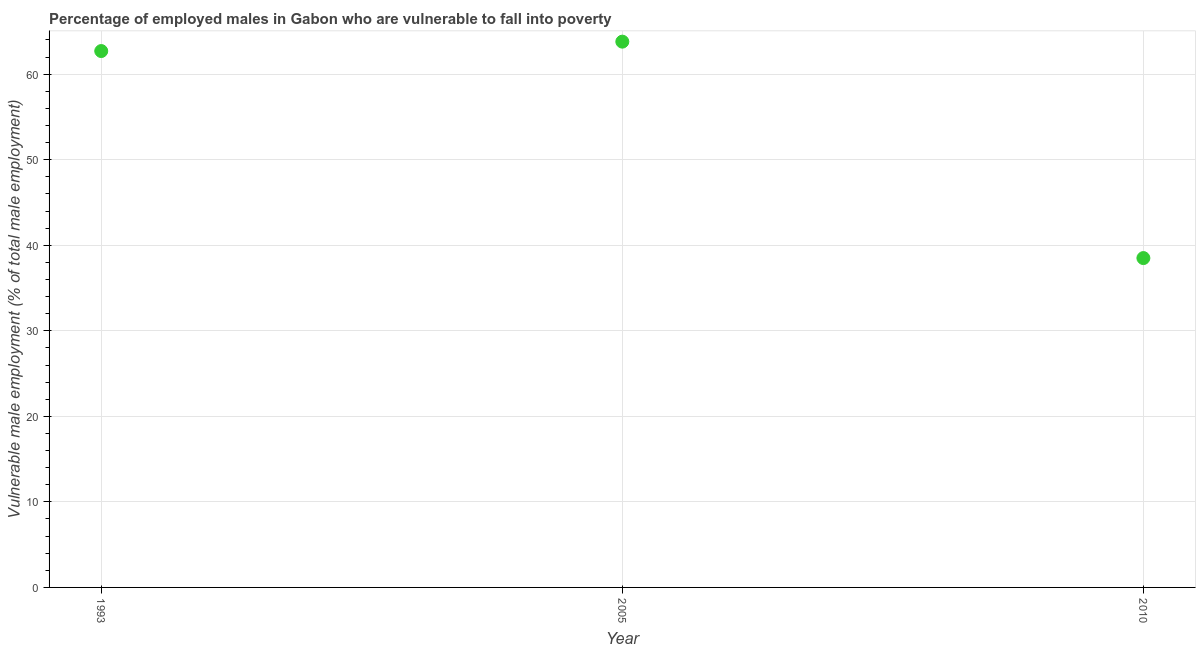What is the percentage of employed males who are vulnerable to fall into poverty in 2005?
Offer a terse response. 63.8. Across all years, what is the maximum percentage of employed males who are vulnerable to fall into poverty?
Ensure brevity in your answer.  63.8. Across all years, what is the minimum percentage of employed males who are vulnerable to fall into poverty?
Make the answer very short. 38.5. In which year was the percentage of employed males who are vulnerable to fall into poverty minimum?
Provide a short and direct response. 2010. What is the sum of the percentage of employed males who are vulnerable to fall into poverty?
Offer a terse response. 165. What is the difference between the percentage of employed males who are vulnerable to fall into poverty in 1993 and 2005?
Offer a very short reply. -1.1. What is the median percentage of employed males who are vulnerable to fall into poverty?
Your response must be concise. 62.7. What is the ratio of the percentage of employed males who are vulnerable to fall into poverty in 1993 to that in 2005?
Offer a terse response. 0.98. What is the difference between the highest and the second highest percentage of employed males who are vulnerable to fall into poverty?
Keep it short and to the point. 1.1. What is the difference between the highest and the lowest percentage of employed males who are vulnerable to fall into poverty?
Your response must be concise. 25.3. How many dotlines are there?
Give a very brief answer. 1. How many years are there in the graph?
Keep it short and to the point. 3. Are the values on the major ticks of Y-axis written in scientific E-notation?
Offer a terse response. No. What is the title of the graph?
Your answer should be compact. Percentage of employed males in Gabon who are vulnerable to fall into poverty. What is the label or title of the Y-axis?
Your answer should be compact. Vulnerable male employment (% of total male employment). What is the Vulnerable male employment (% of total male employment) in 1993?
Your answer should be very brief. 62.7. What is the Vulnerable male employment (% of total male employment) in 2005?
Keep it short and to the point. 63.8. What is the Vulnerable male employment (% of total male employment) in 2010?
Provide a succinct answer. 38.5. What is the difference between the Vulnerable male employment (% of total male employment) in 1993 and 2005?
Your answer should be very brief. -1.1. What is the difference between the Vulnerable male employment (% of total male employment) in 1993 and 2010?
Your answer should be very brief. 24.2. What is the difference between the Vulnerable male employment (% of total male employment) in 2005 and 2010?
Provide a short and direct response. 25.3. What is the ratio of the Vulnerable male employment (% of total male employment) in 1993 to that in 2005?
Give a very brief answer. 0.98. What is the ratio of the Vulnerable male employment (% of total male employment) in 1993 to that in 2010?
Your answer should be compact. 1.63. What is the ratio of the Vulnerable male employment (% of total male employment) in 2005 to that in 2010?
Keep it short and to the point. 1.66. 